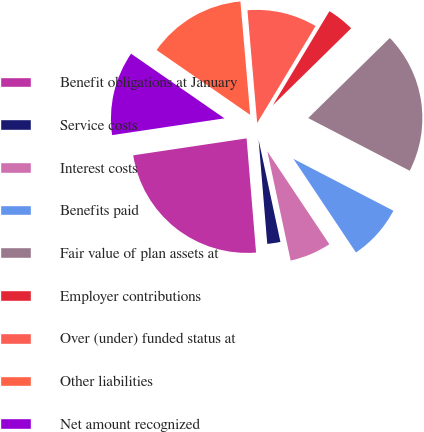Convert chart. <chart><loc_0><loc_0><loc_500><loc_500><pie_chart><fcel>Benefit obligations at January<fcel>Service costs<fcel>Interest costs<fcel>Benefits paid<fcel>Fair value of plan assets at<fcel>Employer contributions<fcel>Over (under) funded status at<fcel>Other liabilities<fcel>Net amount recognized<nl><fcel>23.96%<fcel>2.03%<fcel>6.02%<fcel>8.01%<fcel>19.97%<fcel>4.02%<fcel>10.0%<fcel>13.99%<fcel>12.0%<nl></chart> 